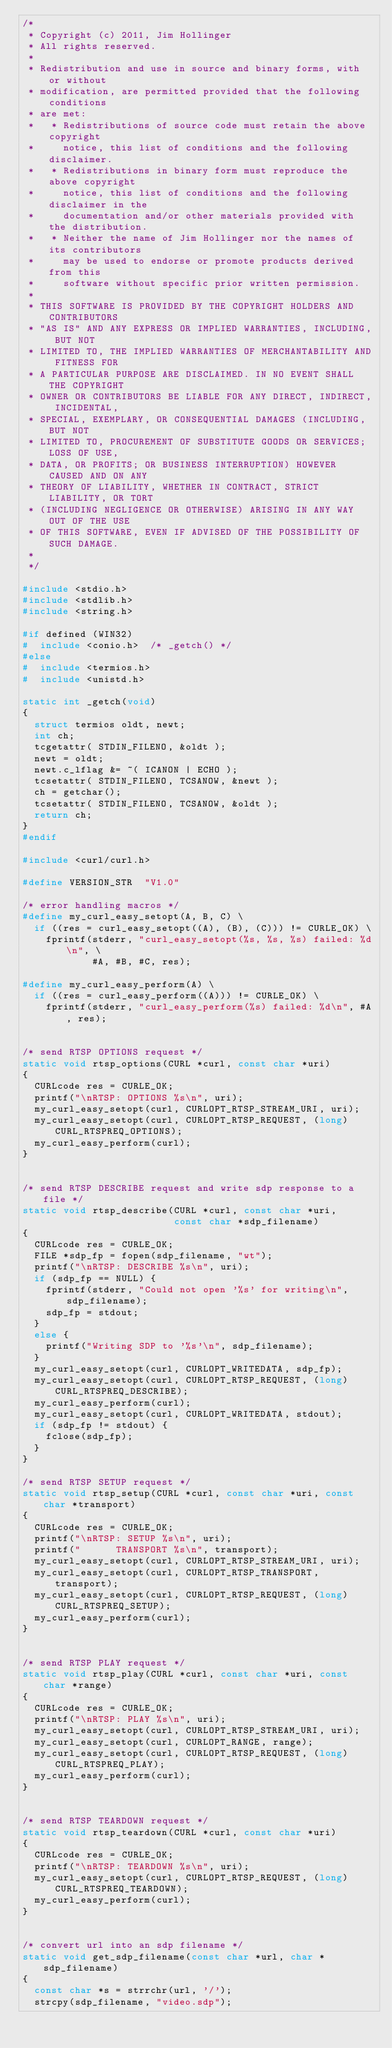Convert code to text. <code><loc_0><loc_0><loc_500><loc_500><_C_>/*
 * Copyright (c) 2011, Jim Hollinger
 * All rights reserved.
 *
 * Redistribution and use in source and binary forms, with or without
 * modification, are permitted provided that the following conditions
 * are met:
 *   * Redistributions of source code must retain the above copyright
 *     notice, this list of conditions and the following disclaimer.
 *   * Redistributions in binary form must reproduce the above copyright
 *     notice, this list of conditions and the following disclaimer in the
 *     documentation and/or other materials provided with the distribution.
 *   * Neither the name of Jim Hollinger nor the names of its contributors
 *     may be used to endorse or promote products derived from this
 *     software without specific prior written permission.
 *
 * THIS SOFTWARE IS PROVIDED BY THE COPYRIGHT HOLDERS AND CONTRIBUTORS
 * "AS IS" AND ANY EXPRESS OR IMPLIED WARRANTIES, INCLUDING, BUT NOT
 * LIMITED TO, THE IMPLIED WARRANTIES OF MERCHANTABILITY AND FITNESS FOR
 * A PARTICULAR PURPOSE ARE DISCLAIMED. IN NO EVENT SHALL THE COPYRIGHT
 * OWNER OR CONTRIBUTORS BE LIABLE FOR ANY DIRECT, INDIRECT, INCIDENTAL,
 * SPECIAL, EXEMPLARY, OR CONSEQUENTIAL DAMAGES (INCLUDING, BUT NOT
 * LIMITED TO, PROCUREMENT OF SUBSTITUTE GOODS OR SERVICES; LOSS OF USE,
 * DATA, OR PROFITS; OR BUSINESS INTERRUPTION) HOWEVER CAUSED AND ON ANY
 * THEORY OF LIABILITY, WHETHER IN CONTRACT, STRICT LIABILITY, OR TORT
 * (INCLUDING NEGLIGENCE OR OTHERWISE) ARISING IN ANY WAY OUT OF THE USE
 * OF THIS SOFTWARE, EVEN IF ADVISED OF THE POSSIBILITY OF SUCH DAMAGE.
 *
 */

#include <stdio.h>
#include <stdlib.h>
#include <string.h>

#if defined (WIN32)
#  include <conio.h>  /* _getch() */
#else
#  include <termios.h>
#  include <unistd.h>

static int _getch(void)
{
  struct termios oldt, newt;
  int ch;
  tcgetattr( STDIN_FILENO, &oldt );
  newt = oldt;
  newt.c_lflag &= ~( ICANON | ECHO );
  tcsetattr( STDIN_FILENO, TCSANOW, &newt );
  ch = getchar();
  tcsetattr( STDIN_FILENO, TCSANOW, &oldt );
  return ch;
}
#endif

#include <curl/curl.h>

#define VERSION_STR  "V1.0"

/* error handling macros */
#define my_curl_easy_setopt(A, B, C) \
  if ((res = curl_easy_setopt((A), (B), (C))) != CURLE_OK) \
    fprintf(stderr, "curl_easy_setopt(%s, %s, %s) failed: %d\n", \
            #A, #B, #C, res);

#define my_curl_easy_perform(A) \
  if ((res = curl_easy_perform((A))) != CURLE_OK) \
    fprintf(stderr, "curl_easy_perform(%s) failed: %d\n", #A, res);


/* send RTSP OPTIONS request */
static void rtsp_options(CURL *curl, const char *uri)
{
  CURLcode res = CURLE_OK;
  printf("\nRTSP: OPTIONS %s\n", uri);
  my_curl_easy_setopt(curl, CURLOPT_RTSP_STREAM_URI, uri);
  my_curl_easy_setopt(curl, CURLOPT_RTSP_REQUEST, (long)CURL_RTSPREQ_OPTIONS);
  my_curl_easy_perform(curl);
}


/* send RTSP DESCRIBE request and write sdp response to a file */
static void rtsp_describe(CURL *curl, const char *uri,
                          const char *sdp_filename)
{
  CURLcode res = CURLE_OK;
  FILE *sdp_fp = fopen(sdp_filename, "wt");
  printf("\nRTSP: DESCRIBE %s\n", uri);
  if (sdp_fp == NULL) {
    fprintf(stderr, "Could not open '%s' for writing\n", sdp_filename);
    sdp_fp = stdout;
  }
  else {
    printf("Writing SDP to '%s'\n", sdp_filename);
  }
  my_curl_easy_setopt(curl, CURLOPT_WRITEDATA, sdp_fp);
  my_curl_easy_setopt(curl, CURLOPT_RTSP_REQUEST, (long)CURL_RTSPREQ_DESCRIBE);
  my_curl_easy_perform(curl);
  my_curl_easy_setopt(curl, CURLOPT_WRITEDATA, stdout);
  if (sdp_fp != stdout) {
    fclose(sdp_fp);
  }
}

/* send RTSP SETUP request */
static void rtsp_setup(CURL *curl, const char *uri, const char *transport)
{
  CURLcode res = CURLE_OK;
  printf("\nRTSP: SETUP %s\n", uri);
  printf("      TRANSPORT %s\n", transport);
  my_curl_easy_setopt(curl, CURLOPT_RTSP_STREAM_URI, uri);
  my_curl_easy_setopt(curl, CURLOPT_RTSP_TRANSPORT, transport);
  my_curl_easy_setopt(curl, CURLOPT_RTSP_REQUEST, (long)CURL_RTSPREQ_SETUP);
  my_curl_easy_perform(curl);
}


/* send RTSP PLAY request */
static void rtsp_play(CURL *curl, const char *uri, const char *range)
{
  CURLcode res = CURLE_OK;
  printf("\nRTSP: PLAY %s\n", uri);
  my_curl_easy_setopt(curl, CURLOPT_RTSP_STREAM_URI, uri);
  my_curl_easy_setopt(curl, CURLOPT_RANGE, range);
  my_curl_easy_setopt(curl, CURLOPT_RTSP_REQUEST, (long)CURL_RTSPREQ_PLAY);
  my_curl_easy_perform(curl);
}


/* send RTSP TEARDOWN request */
static void rtsp_teardown(CURL *curl, const char *uri)
{
  CURLcode res = CURLE_OK;
  printf("\nRTSP: TEARDOWN %s\n", uri);
  my_curl_easy_setopt(curl, CURLOPT_RTSP_REQUEST, (long)CURL_RTSPREQ_TEARDOWN);
  my_curl_easy_perform(curl);
}


/* convert url into an sdp filename */
static void get_sdp_filename(const char *url, char *sdp_filename)
{
  const char *s = strrchr(url, '/');
  strcpy(sdp_filename, "video.sdp");</code> 